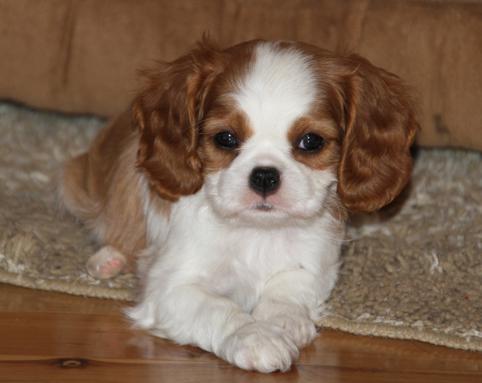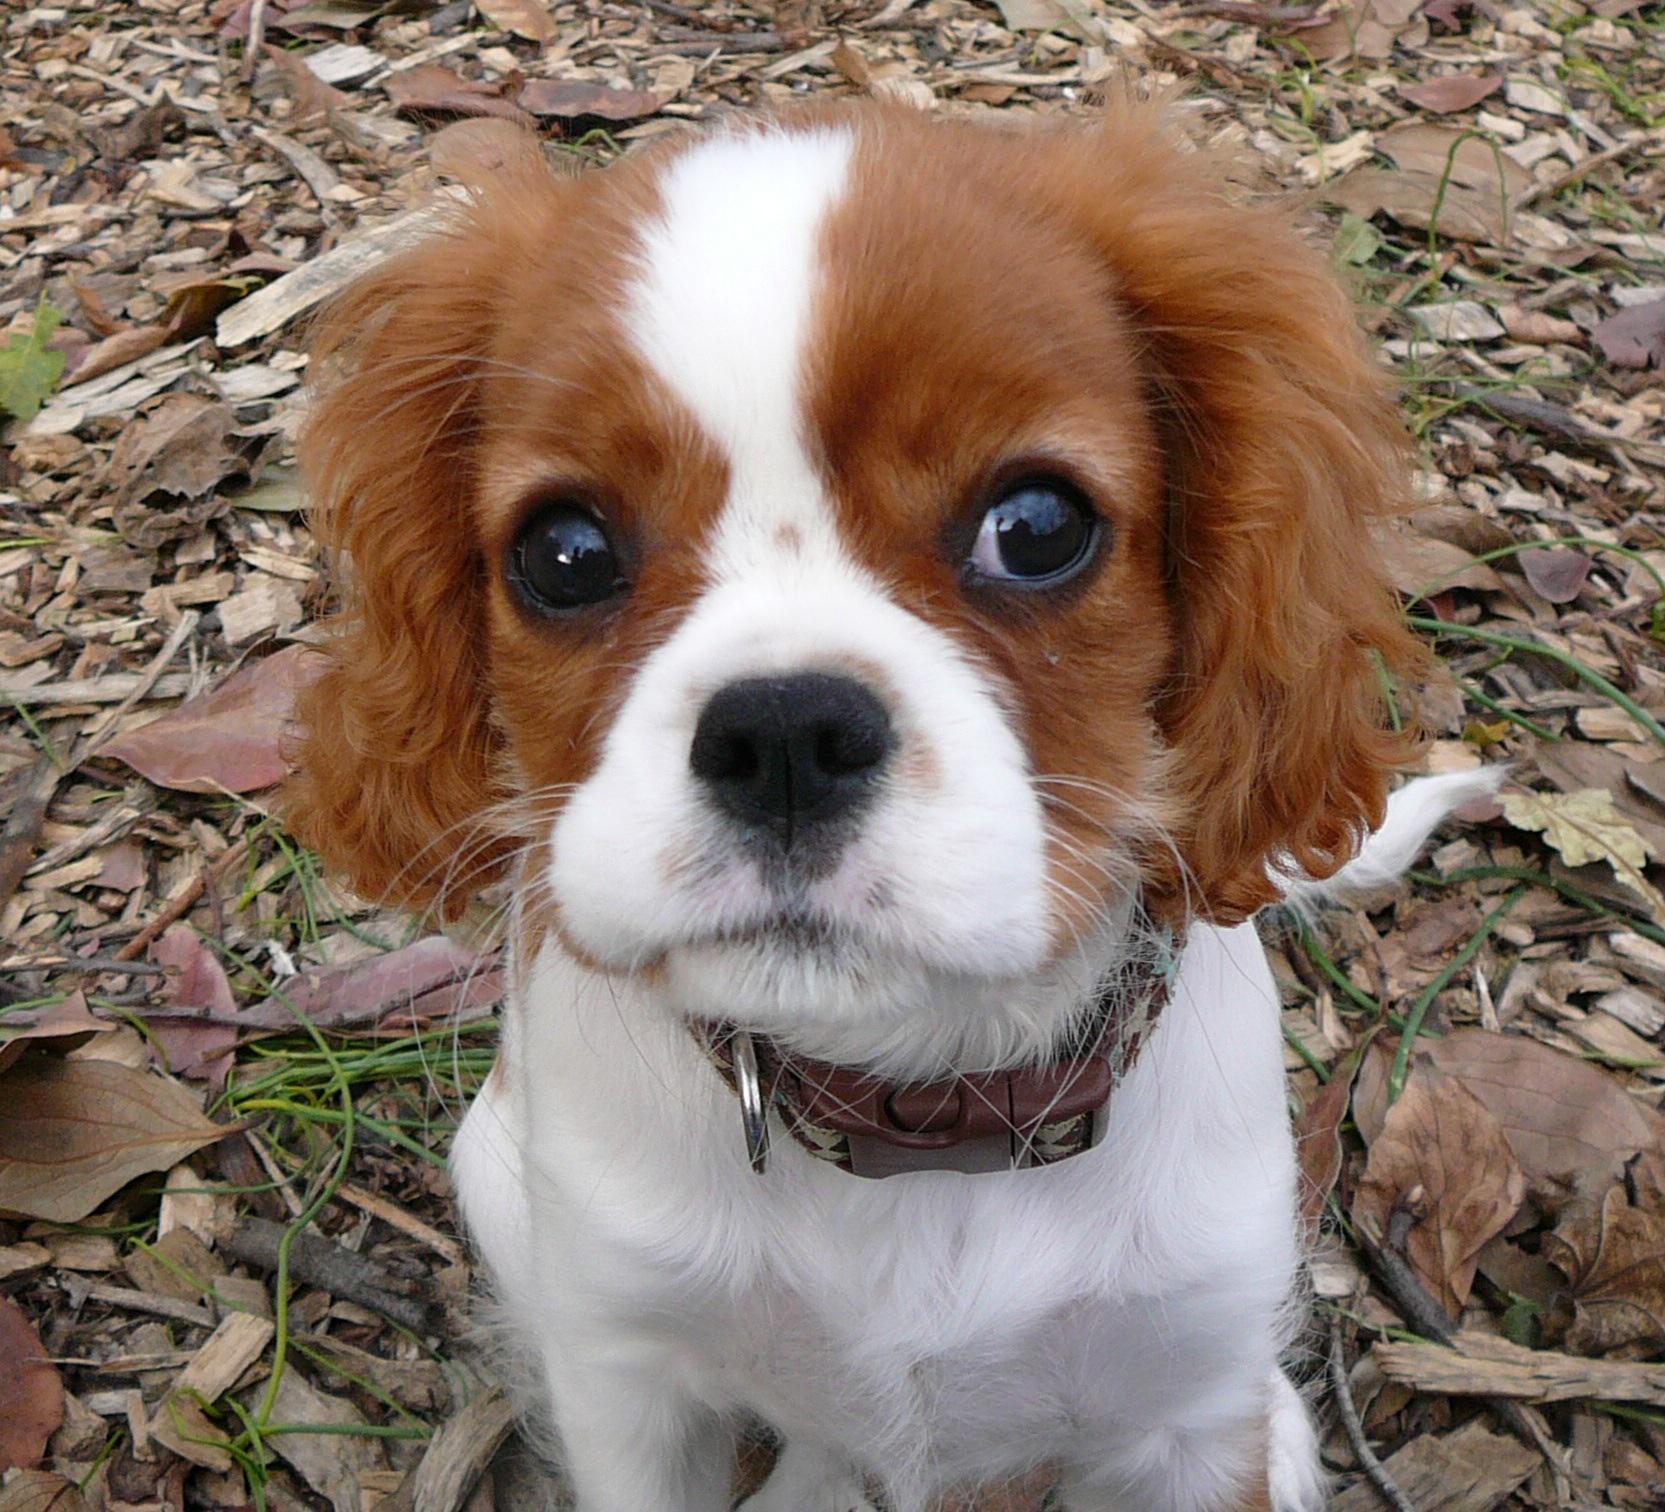The first image is the image on the left, the second image is the image on the right. For the images displayed, is the sentence "In one of the images, the puppy is lying down with its chin resting on something" factually correct? Answer yes or no. No. 